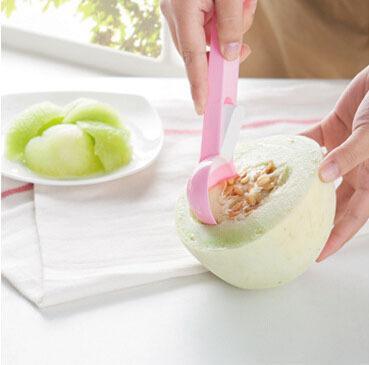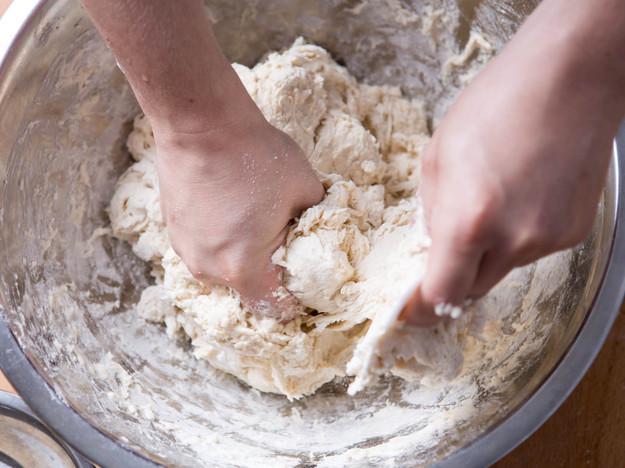The first image is the image on the left, the second image is the image on the right. Given the left and right images, does the statement "Each image shows a utensil in a bowl of food mixture, and one image shows one hand stirring with the utensil as the other hand holds the edge of the bowl." hold true? Answer yes or no. No. 